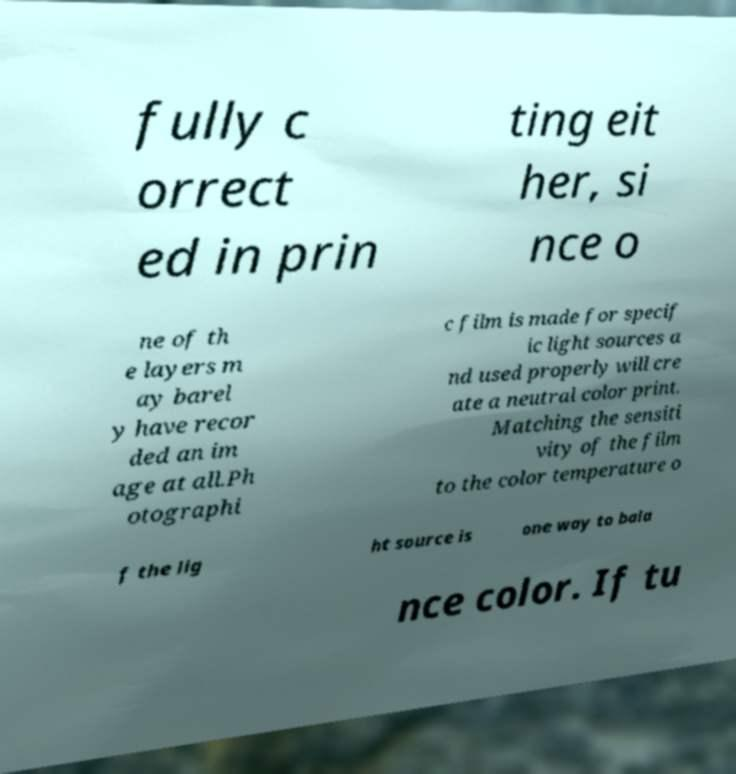There's text embedded in this image that I need extracted. Can you transcribe it verbatim? fully c orrect ed in prin ting eit her, si nce o ne of th e layers m ay barel y have recor ded an im age at all.Ph otographi c film is made for specif ic light sources a nd used properly will cre ate a neutral color print. Matching the sensiti vity of the film to the color temperature o f the lig ht source is one way to bala nce color. If tu 